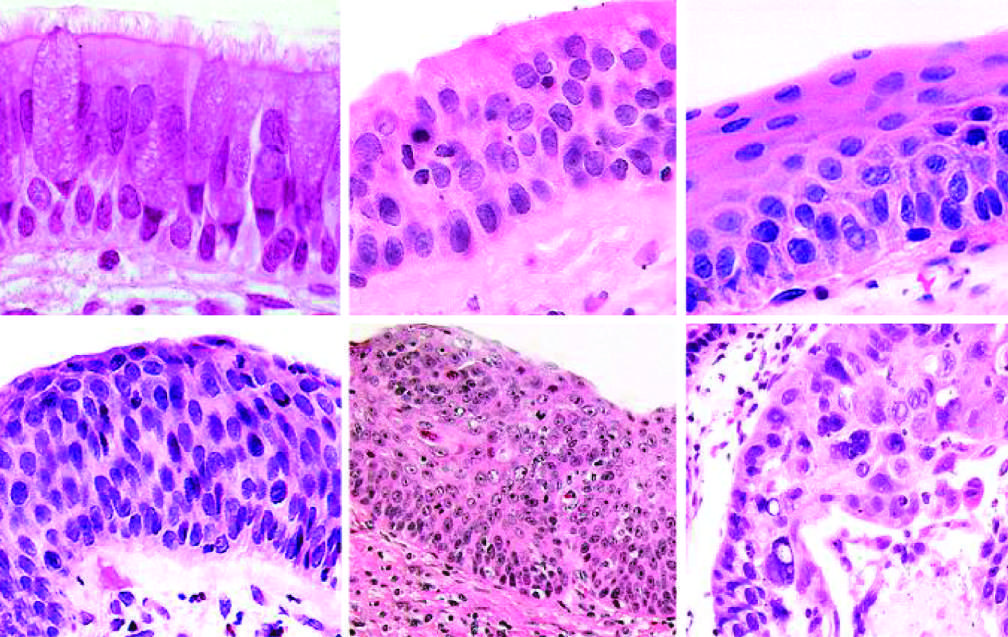s carcinoma in situ the stage that immediately precedes invasive squamous cell carcinoma?
Answer the question using a single word or phrase. Yes 